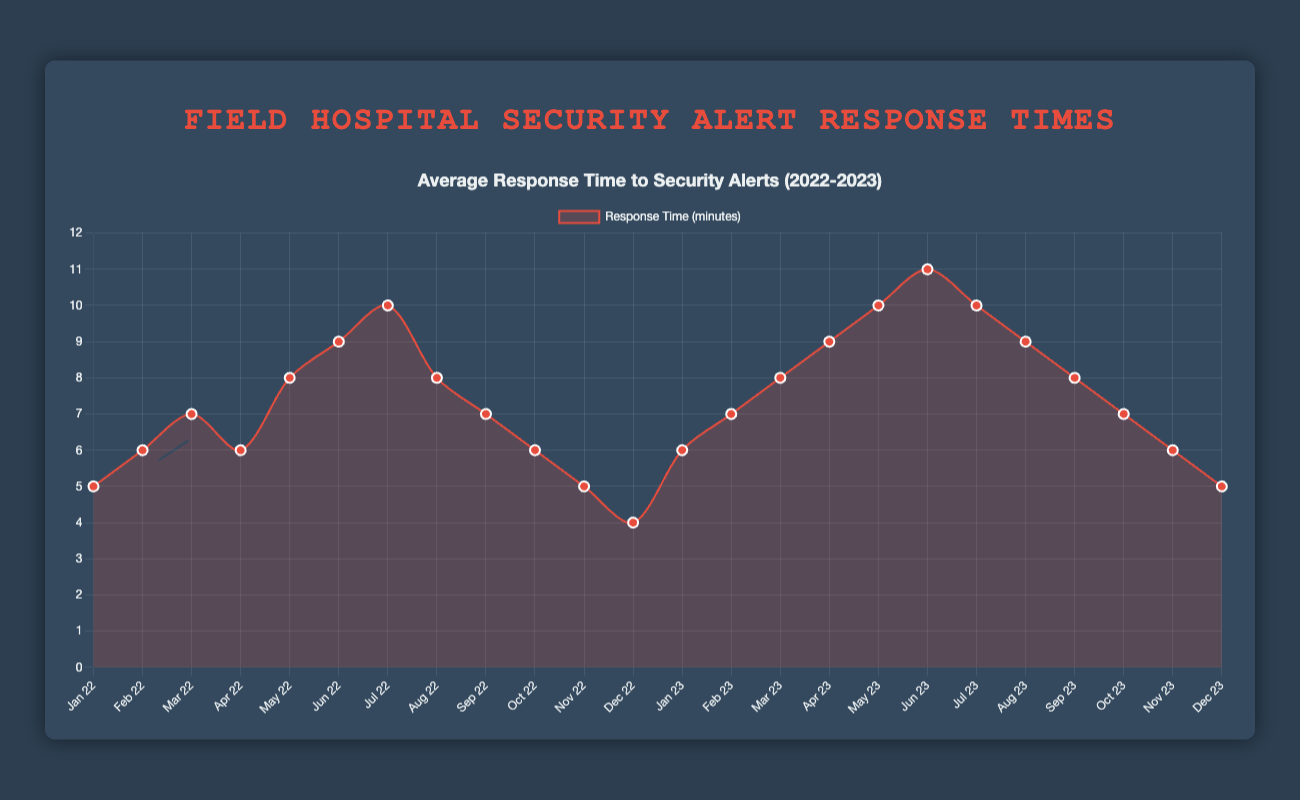Which month had the shortest average response time in 2022? To find the shortest average response time in 2022, look at the lowest point on the chart for 2022. This is in December 2022 with 4 minutes.
Answer: December 2022 How did the response time change from January 2023 to June 2023? The response time began at 6 minutes in January 2023, then increased by 1 minute each month, reaching 11 minutes in June 2023.
Answer: Increased by 5 minutes Between which two months did the largest increase in response time occur? To determine this, look at the differences between consecutive months. The largest increase is from June 2022 (9 minutes) to July 2022 (10 minutes) and from June 2023 (11 minutes) to July 2023 (10 minutes).
Answer: June 2022 to July 2022 Which month in 2023 had the same average response time as November 2022? Identify November 2022 with a response time of 5 minutes. The month in 2023 that matches this is December 2023.
Answer: December 2023 Compare the average response time between August 2022 and August 2023. Which is higher? To compare, examine the chart values for both August 2022 and August 2023. August 2022 had 8 minutes, while August 2023 had 9 minutes.
Answer: August 2023 What is the trend in average response time from May 2022 to December 2022? Starting at 8 minutes in May, the trend shows a decrease to 4 minutes by December 2022.
Answer: Decreasing What was the average response time over the entire period from January 2022 to December 2023? Add the response times for all months and divide by the number of months (24). The sum is (5+6+7+6+8+9+10+8+7+6+5+4+6+7+8+9+10+11+10+9+8+7+6+5)=168, so the average is 168/24=7 minutes.
Answer: 7 minutes How does the December average response time differ between 2022 and 2023? Compare December 2022 (4 minutes) and December 2023 (5 minutes). The response time increased by 1 minute.
Answer: Increased by 1 minute 